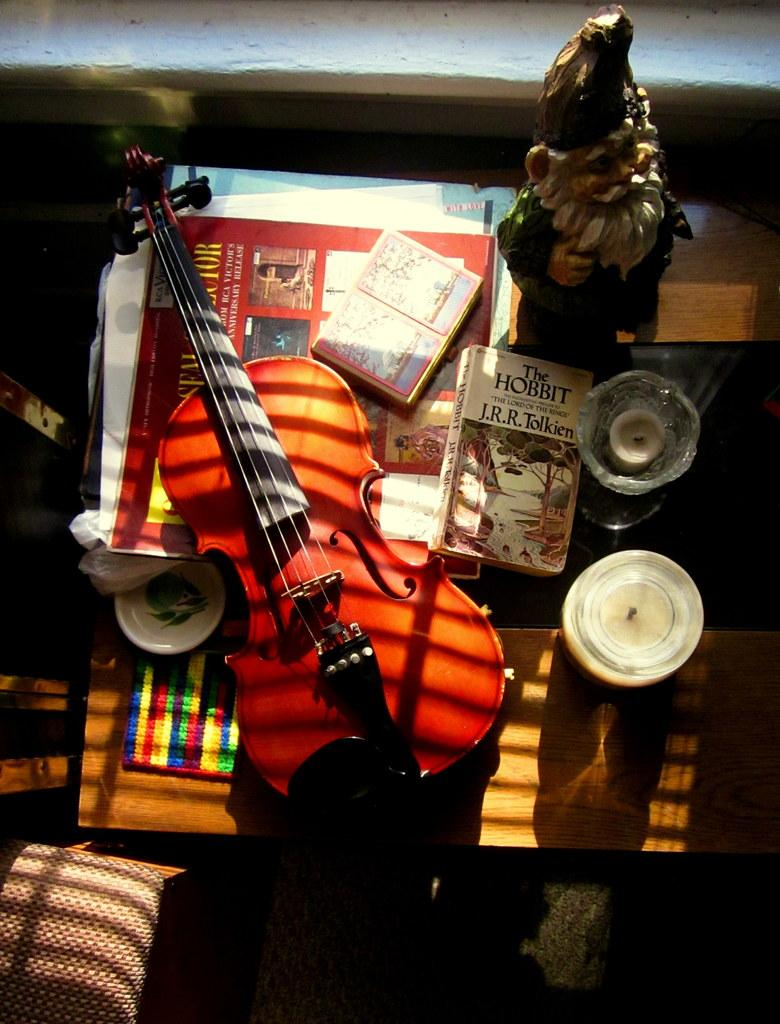What musical instrument is on the table in the image? There is a guitar on the table in the image. What else can be found on the table besides the guitar? There are books and magazines on the table. Is there any holiday-related decoration on the table? Yes, there is a Santa Claus statue on the table. What type of cloth is draped over the guitar in the image? There is no cloth draped over the guitar in the image. What type of beef dish is being served on the table in the image? There is no beef dish present in the image. 